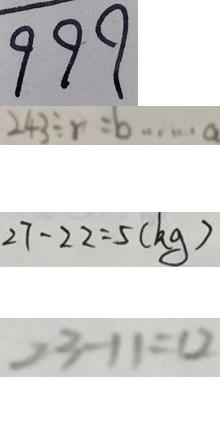<formula> <loc_0><loc_0><loc_500><loc_500>9 9 9 
 2 4 3 \div r = b \cdots a 
 2 7 - 2 2 = 5 ( k g ) 
 2 3 - 1 1 = 1 2</formula> 